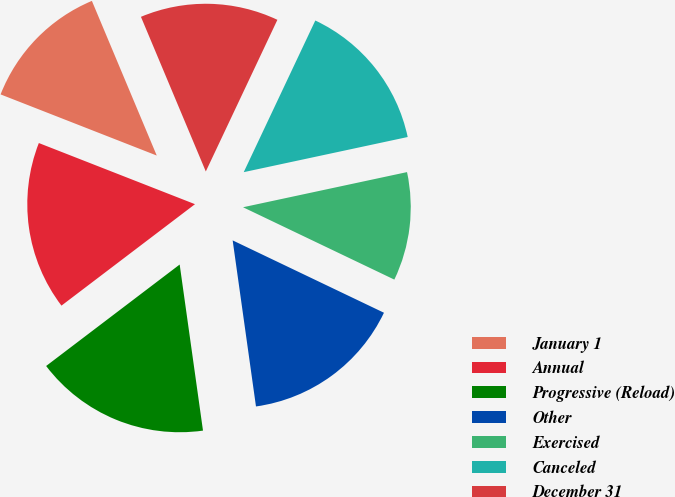Convert chart to OTSL. <chart><loc_0><loc_0><loc_500><loc_500><pie_chart><fcel>January 1<fcel>Annual<fcel>Progressive (Reload)<fcel>Other<fcel>Exercised<fcel>Canceled<fcel>December 31<nl><fcel>12.74%<fcel>16.28%<fcel>16.88%<fcel>15.68%<fcel>10.46%<fcel>14.62%<fcel>13.34%<nl></chart> 